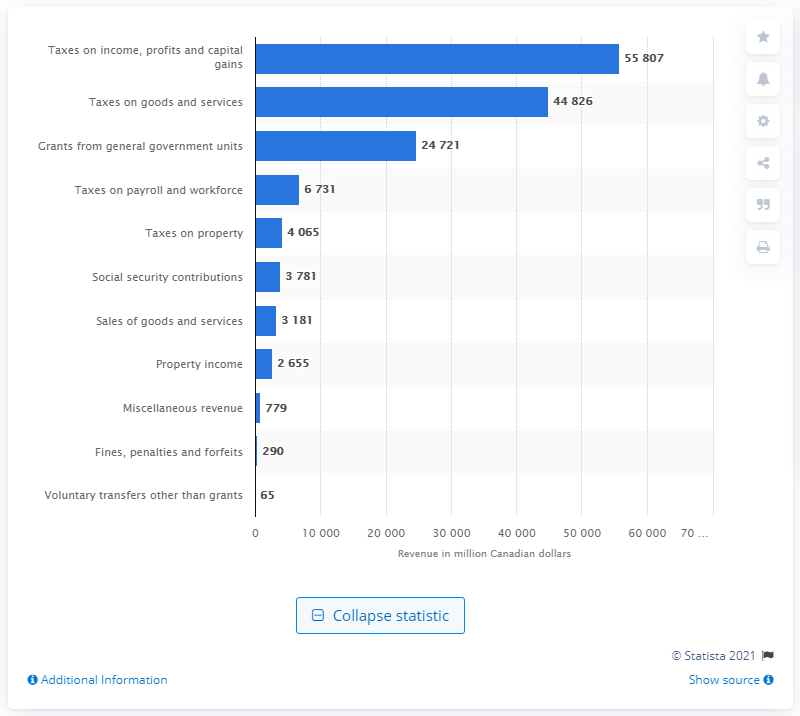Highlight a few significant elements in this photo. The Ontario government collected approximately $448,260 in revenue through taxes on goods and services in 2019. 